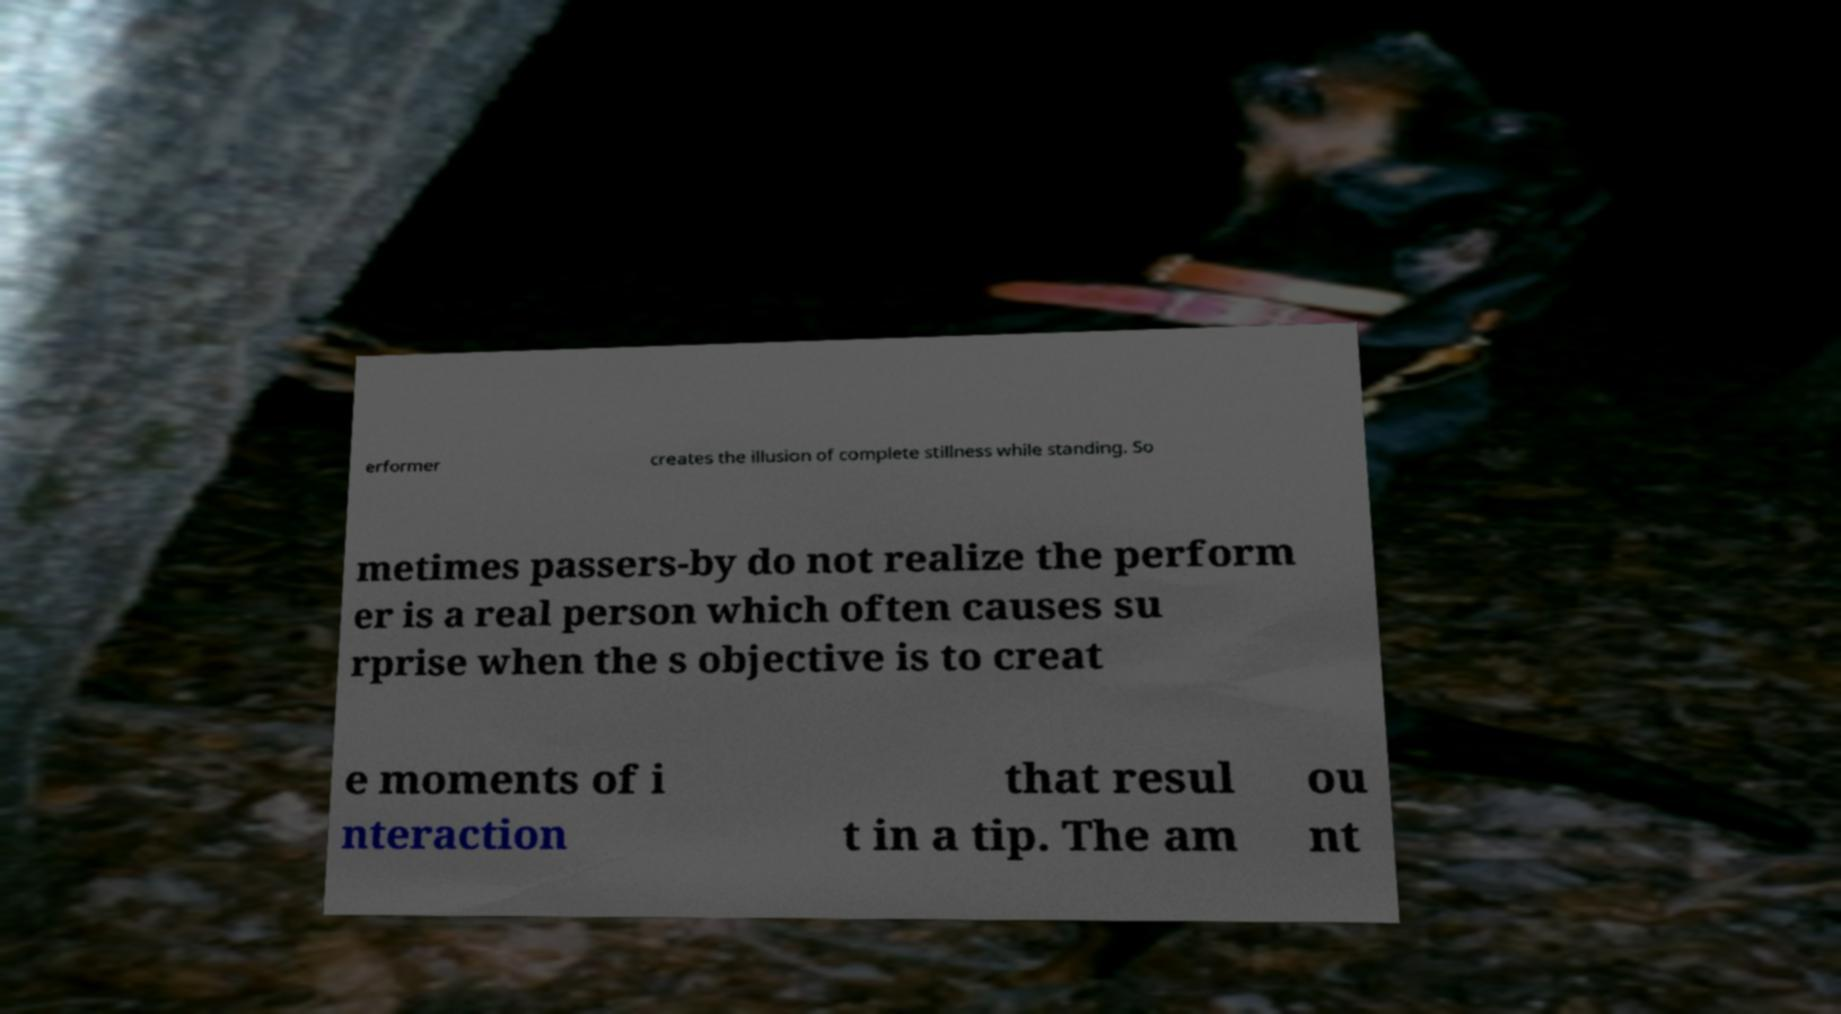Please identify and transcribe the text found in this image. erformer creates the illusion of complete stillness while standing. So metimes passers-by do not realize the perform er is a real person which often causes su rprise when the s objective is to creat e moments of i nteraction that resul t in a tip. The am ou nt 